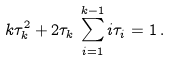<formula> <loc_0><loc_0><loc_500><loc_500>k \tau _ { k } ^ { 2 } + 2 \tau _ { k } \, \sum _ { i = 1 } ^ { k - 1 } i \tau _ { i } = 1 \, .</formula> 